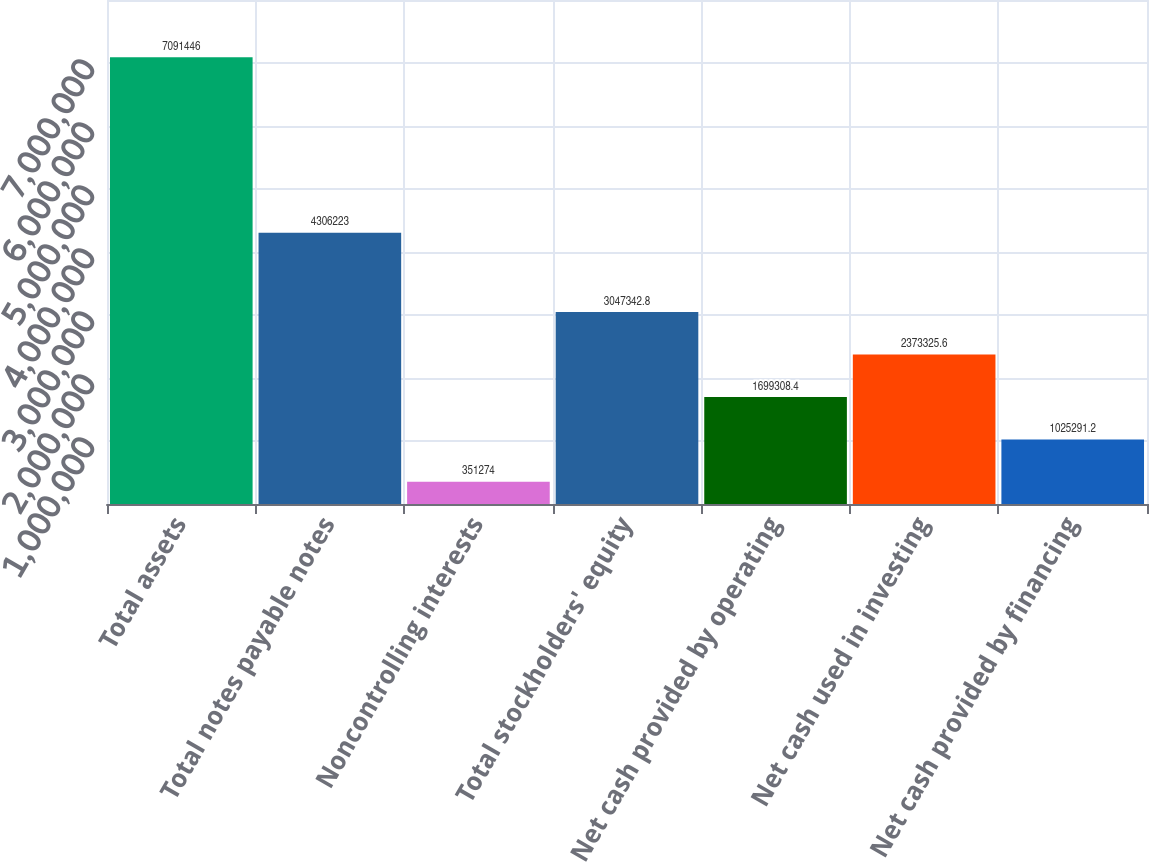<chart> <loc_0><loc_0><loc_500><loc_500><bar_chart><fcel>Total assets<fcel>Total notes payable notes<fcel>Noncontrolling interests<fcel>Total stockholders' equity<fcel>Net cash provided by operating<fcel>Net cash used in investing<fcel>Net cash provided by financing<nl><fcel>7.09145e+06<fcel>4.30622e+06<fcel>351274<fcel>3.04734e+06<fcel>1.69931e+06<fcel>2.37333e+06<fcel>1.02529e+06<nl></chart> 